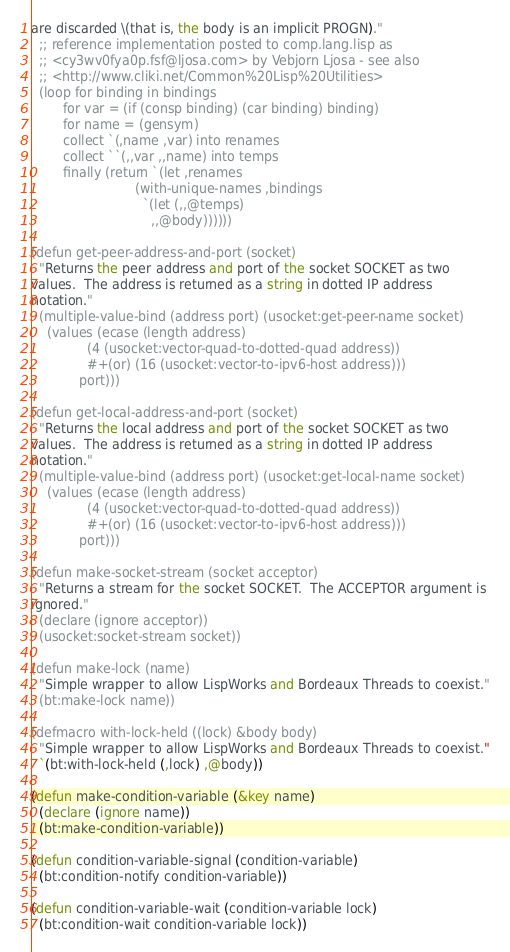<code> <loc_0><loc_0><loc_500><loc_500><_Lisp_>are discarded \(that is, the body is an implicit PROGN)."
  ;; reference implementation posted to comp.lang.lisp as
  ;; <cy3wv0fya0p.fsf@ljosa.com> by Vebjorn Ljosa - see also
  ;; <http://www.cliki.net/Common%20Lisp%20Utilities>
  (loop for binding in bindings
        for var = (if (consp binding) (car binding) binding)
        for name = (gensym)
        collect `(,name ,var) into renames
        collect ``(,,var ,,name) into temps
        finally (return `(let ,renames
                          (with-unique-names ,bindings
                            `(let (,,@temps)
                              ,,@body))))))

(defun get-peer-address-and-port (socket)
  "Returns the peer address and port of the socket SOCKET as two
values.  The address is returned as a string in dotted IP address
notation."
  (multiple-value-bind (address port) (usocket:get-peer-name socket)
    (values (ecase (length address)
              (4 (usocket:vector-quad-to-dotted-quad address))
              #+(or) (16 (usocket:vector-to-ipv6-host address)))
            port)))

(defun get-local-address-and-port (socket)
  "Returns the local address and port of the socket SOCKET as two
values.  The address is returned as a string in dotted IP address
notation."
  (multiple-value-bind (address port) (usocket:get-local-name socket)
    (values (ecase (length address)
              (4 (usocket:vector-quad-to-dotted-quad address))
              #+(or) (16 (usocket:vector-to-ipv6-host address)))
            port)))

(defun make-socket-stream (socket acceptor)
  "Returns a stream for the socket SOCKET.  The ACCEPTOR argument is
ignored."
  (declare (ignore acceptor))
  (usocket:socket-stream socket))

(defun make-lock (name)
  "Simple wrapper to allow LispWorks and Bordeaux Threads to coexist."
  (bt:make-lock name))

(defmacro with-lock-held ((lock) &body body)
  "Simple wrapper to allow LispWorks and Bordeaux Threads to coexist."
  `(bt:with-lock-held (,lock) ,@body))

(defun make-condition-variable (&key name)
  (declare (ignore name))
  (bt:make-condition-variable))

(defun condition-variable-signal (condition-variable)
  (bt:condition-notify condition-variable))

(defun condition-variable-wait (condition-variable lock)
  (bt:condition-wait condition-variable lock))
</code> 